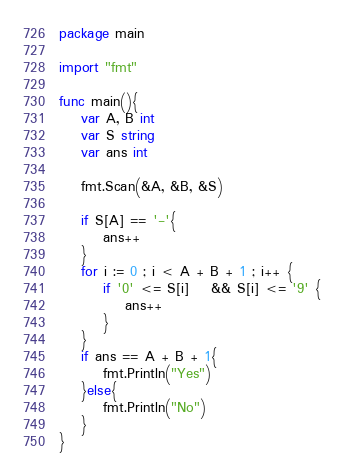<code> <loc_0><loc_0><loc_500><loc_500><_Go_>package main

import "fmt"

func main(){
	var A, B int
	var S string
	var ans int

	fmt.Scan(&A, &B, &S)

	if S[A] == '-'{
		ans++
	}
	for i := 0 ; i < A + B + 1 ; i++ {
		if '0' <= S[i]	&& S[i] <= '9' {
			ans++
		}
	}
	if ans == A + B + 1{
		fmt.Println("Yes")
	}else{
		fmt.Println("No")
	}
}</code> 